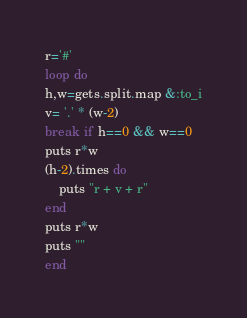<code> <loc_0><loc_0><loc_500><loc_500><_Ruby_>r='#'
loop do
h,w=gets.split.map &:to_i
v= '.' * (w-2)
break if h==0 && w==0
puts r*w
(h-2).times do 
    puts "r + v + r"
end
puts r*w
puts ""
end
</code> 